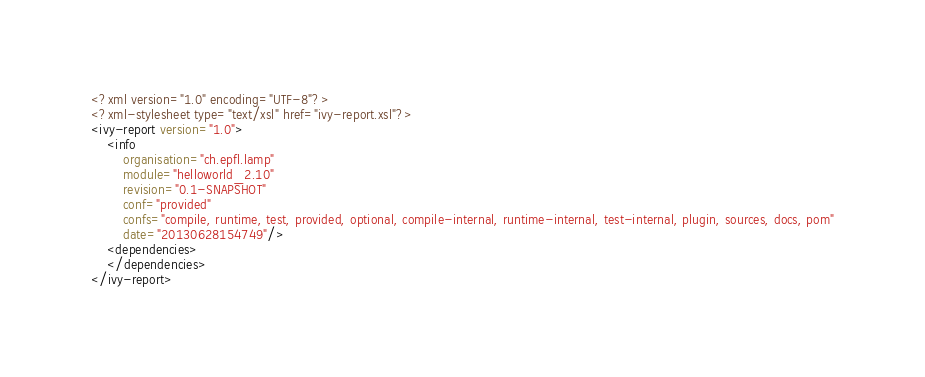<code> <loc_0><loc_0><loc_500><loc_500><_XML_><?xml version="1.0" encoding="UTF-8"?>
<?xml-stylesheet type="text/xsl" href="ivy-report.xsl"?>
<ivy-report version="1.0">
	<info
		organisation="ch.epfl.lamp"
		module="helloworld_2.10"
		revision="0.1-SNAPSHOT"
		conf="provided"
		confs="compile, runtime, test, provided, optional, compile-internal, runtime-internal, test-internal, plugin, sources, docs, pom"
		date="20130628154749"/>
	<dependencies>
	</dependencies>
</ivy-report>
</code> 